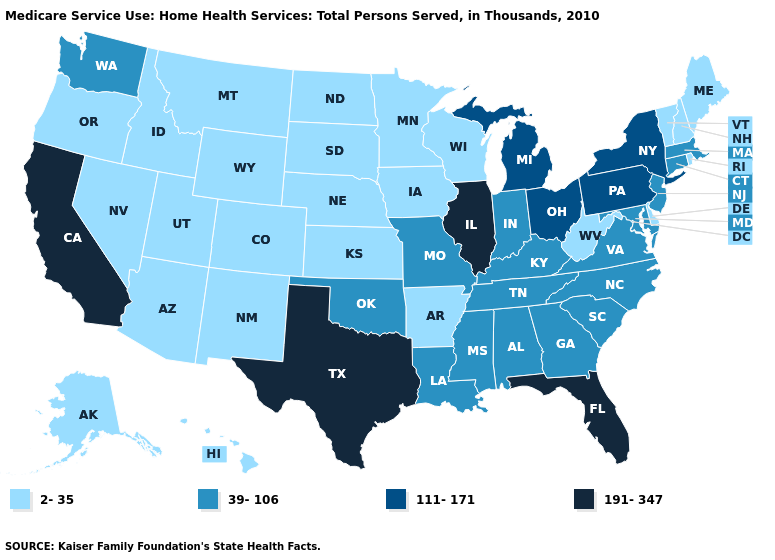Which states have the lowest value in the USA?
Give a very brief answer. Alaska, Arizona, Arkansas, Colorado, Delaware, Hawaii, Idaho, Iowa, Kansas, Maine, Minnesota, Montana, Nebraska, Nevada, New Hampshire, New Mexico, North Dakota, Oregon, Rhode Island, South Dakota, Utah, Vermont, West Virginia, Wisconsin, Wyoming. Does New York have a lower value than Ohio?
Concise answer only. No. What is the value of Oregon?
Concise answer only. 2-35. Which states have the lowest value in the USA?
Concise answer only. Alaska, Arizona, Arkansas, Colorado, Delaware, Hawaii, Idaho, Iowa, Kansas, Maine, Minnesota, Montana, Nebraska, Nevada, New Hampshire, New Mexico, North Dakota, Oregon, Rhode Island, South Dakota, Utah, Vermont, West Virginia, Wisconsin, Wyoming. What is the value of Mississippi?
Short answer required. 39-106. What is the value of Mississippi?
Quick response, please. 39-106. Name the states that have a value in the range 2-35?
Give a very brief answer. Alaska, Arizona, Arkansas, Colorado, Delaware, Hawaii, Idaho, Iowa, Kansas, Maine, Minnesota, Montana, Nebraska, Nevada, New Hampshire, New Mexico, North Dakota, Oregon, Rhode Island, South Dakota, Utah, Vermont, West Virginia, Wisconsin, Wyoming. Name the states that have a value in the range 111-171?
Quick response, please. Michigan, New York, Ohio, Pennsylvania. Does the map have missing data?
Write a very short answer. No. What is the value of New Hampshire?
Concise answer only. 2-35. What is the value of Delaware?
Concise answer only. 2-35. Name the states that have a value in the range 2-35?
Give a very brief answer. Alaska, Arizona, Arkansas, Colorado, Delaware, Hawaii, Idaho, Iowa, Kansas, Maine, Minnesota, Montana, Nebraska, Nevada, New Hampshire, New Mexico, North Dakota, Oregon, Rhode Island, South Dakota, Utah, Vermont, West Virginia, Wisconsin, Wyoming. Name the states that have a value in the range 191-347?
Answer briefly. California, Florida, Illinois, Texas. Among the states that border Alabama , does Mississippi have the highest value?
Be succinct. No. Name the states that have a value in the range 191-347?
Concise answer only. California, Florida, Illinois, Texas. 